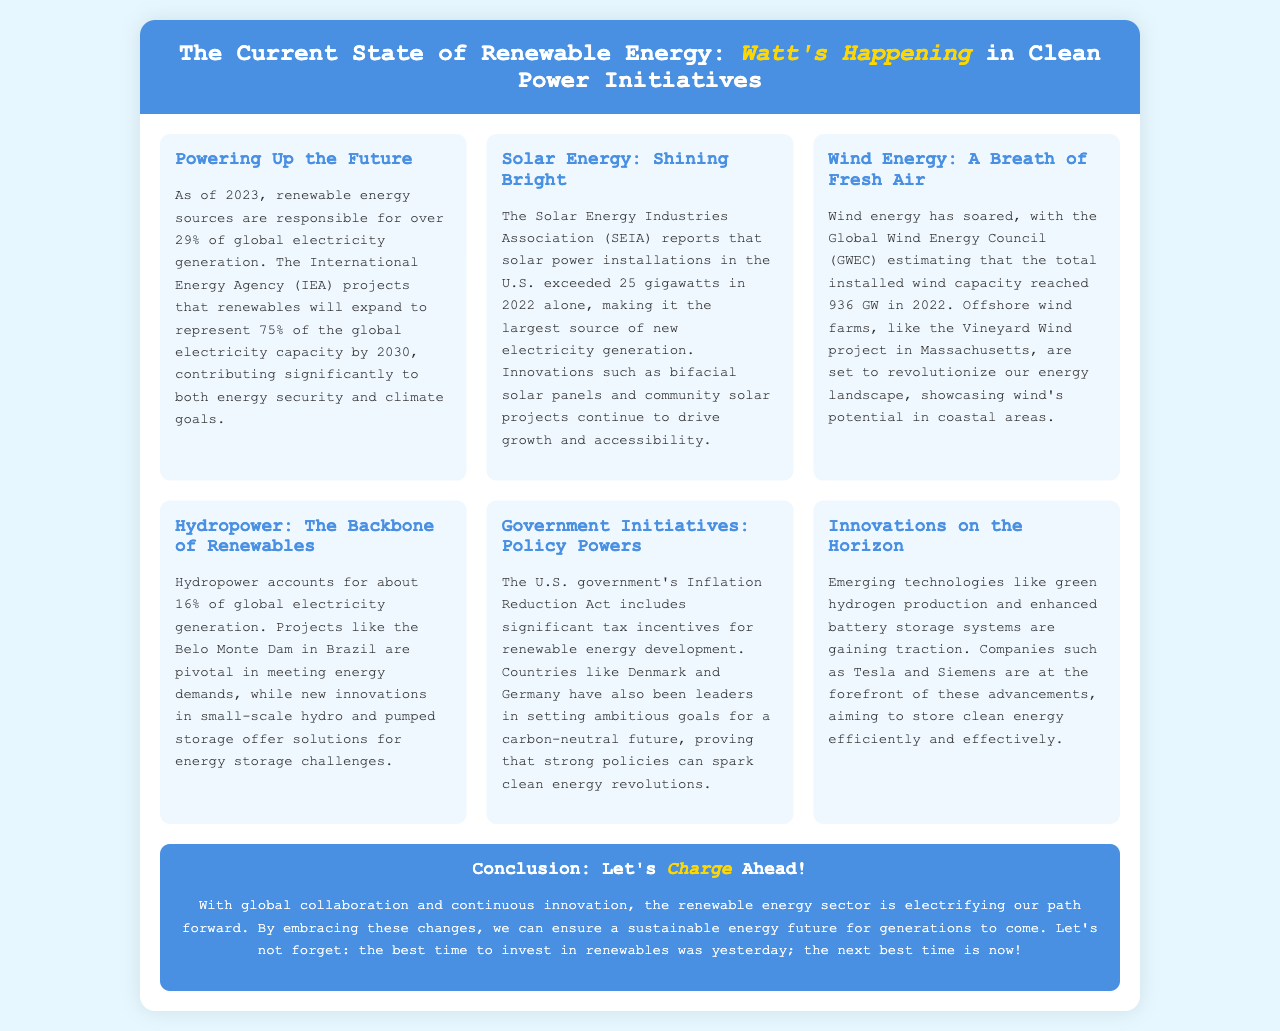What percentage of global electricity generation is from renewable energy as of 2023? The document states that renewable energy sources are responsible for over 29% of global electricity generation as of 2023.
Answer: 29% How much solar power was installed in the U.S. in 2022? According to the Solar Energy Industries Association, solar power installations in the U.S. exceeded 25 gigawatts in 2022.
Answer: 25 gigawatts What is the total installed wind capacity estimated to be in 2022? The Global Wind Energy Council estimates that the total installed wind capacity reached 936 GW in 2022.
Answer: 936 GW Which U.S. act includes significant tax incentives for renewable energy? The document mentions that the Inflation Reduction Act includes significant tax incentives for renewable energy development.
Answer: Inflation Reduction Act What is the primary renewable energy source contributing 16% of global electricity generation? The document indicates that hydropower accounts for about 16% of global electricity generation.
Answer: Hydropower Which wind project in Massachusetts is mentioned as revolutionary? The Vineyard Wind project in Massachusetts is highlighted as a groundbreaking offshore wind farm.
Answer: Vineyard Wind What technology is emerging for efficient clean energy storage? The document refers to enhanced battery storage systems as an emerging technology for storing clean energy effectively.
Answer: Enhanced battery storage systems What do companies like Tesla and Siemens focus on in the renewable energy sector? The document points out that companies such as Tesla and Siemens are at the forefront of green hydrogen production and enhanced battery storage advancements.
Answer: Green hydrogen production and enhanced battery storage What color scheme does the brochure primarily use? The header's background color and the general aesthetic suggest a blue theme throughout the brochure.
Answer: Blue 